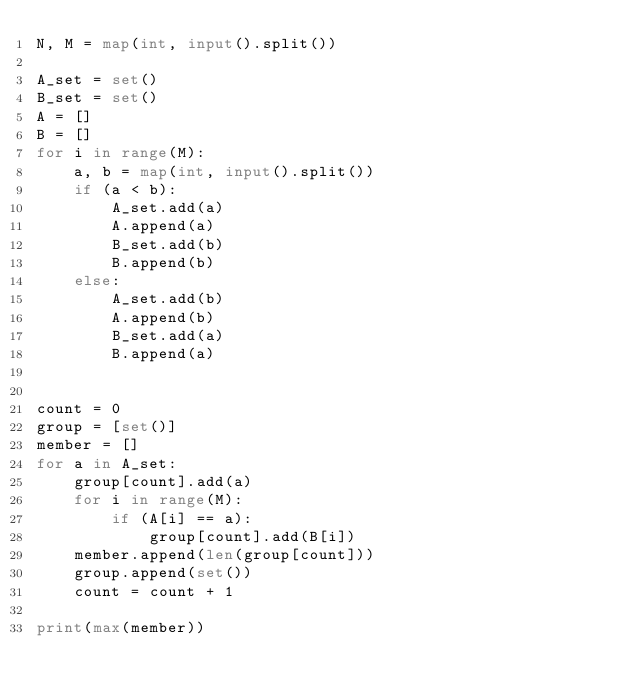Convert code to text. <code><loc_0><loc_0><loc_500><loc_500><_Python_>N, M = map(int, input().split())

A_set = set()
B_set = set()
A = []
B = []
for i in range(M):
    a, b = map(int, input().split())
    if (a < b):
        A_set.add(a)
        A.append(a)
        B_set.add(b)
        B.append(b)
    else:
        A_set.add(b)
        A.append(b)
        B_set.add(a)
        B.append(a)


count = 0
group = [set()]
member = []
for a in A_set:
    group[count].add(a)
    for i in range(M):
        if (A[i] == a):
            group[count].add(B[i])    
    member.append(len(group[count]))
    group.append(set())
    count = count + 1

print(max(member))</code> 